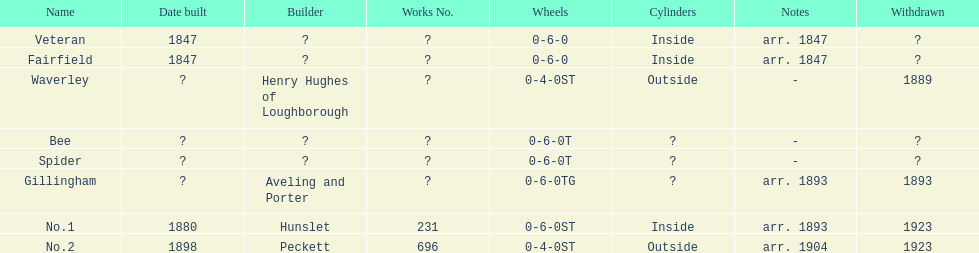What was the number of constructions in 1847? 2. 